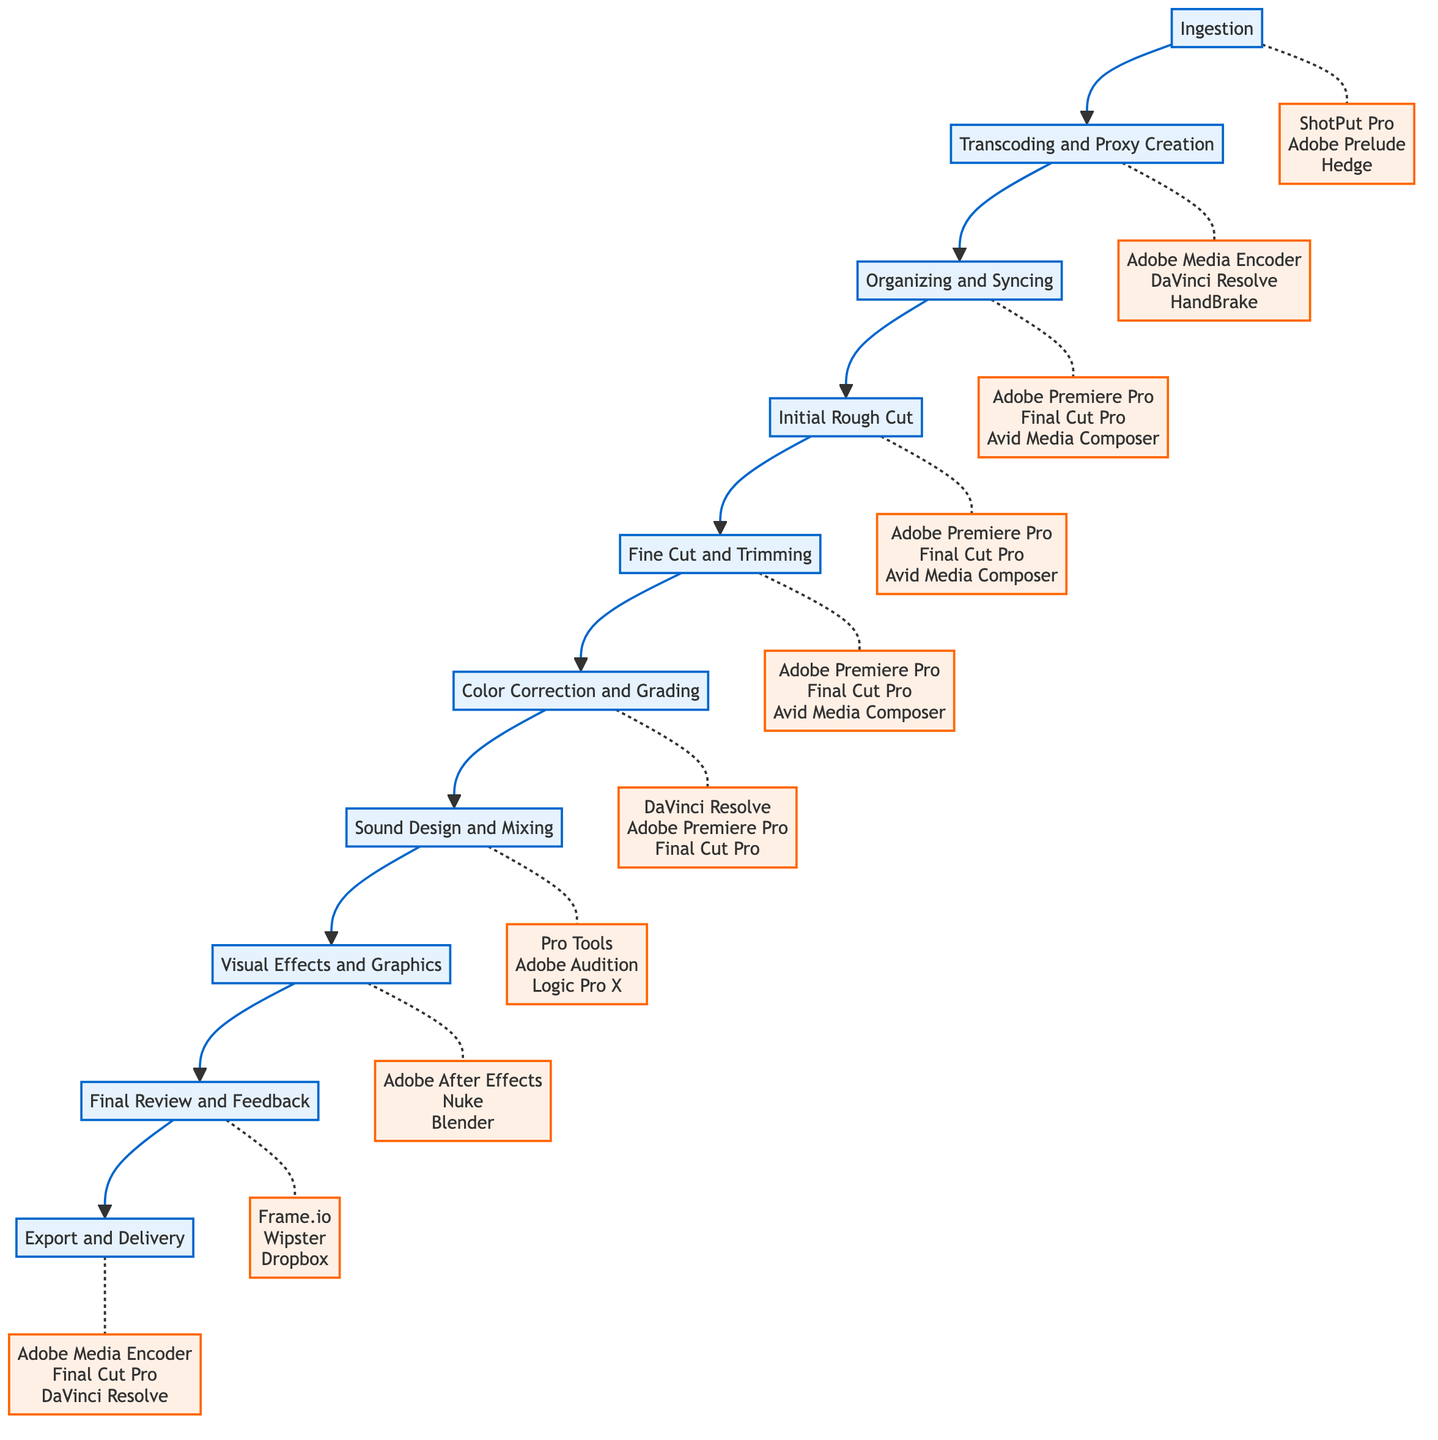What is the first step in the post-production workflow? The first node in the flow chart is labeled "Ingestion," which indicates that it is the starting point of the post-production process.
Answer: Ingestion How many steps are there in the post-production workflow? There are ten steps represented in the flow chart, each leading to the next in the process of post-production.
Answer: 10 What tools are used in the "Fine Cut and Trimming" step? The "Fine Cut and Trimming" step references three specific tools with the labels provided in the flow chart: "Adobe Premiere Pro," "Final Cut Pro," and "Avid Media Composer."
Answer: Adobe Premiere Pro, Final Cut Pro, Avid Media Composer What comes after "Color Correction and Grading"? By following the arrows in the flow chart, it can be observed that the next step after "Color Correction and Grading" is "Sound Design and Mixing," indicating the progression of tasks in the workflow.
Answer: Sound Design and Mixing How does "Transcoding and Proxy Creation" relate to "Ingestion"? The flow chart shows a direct arrow from "Ingestion" to "Transcoding and Proxy Creation," illustrating that transcoding occurs immediately after the ingestion of raw footage, representing a sequential relationship.
Answer: Transcoding and Proxy Creation Which step involves enhancing visual aesthetics? "Color Correction and Grading" is specifically named in the flow chart to indicate that it is the step focused on adjusting the visual aesthetics and color balance of the footage.
Answer: Color Correction and Grading Name a tool used in "Visual Effects and Graphics". The flow chart lists three tools under "Visual Effects and Graphics," including "Adobe After Effects," which is one of the specific tools designated for this step.
Answer: Adobe After Effects Which step must be completed before the "Final Review and Feedback"? The "Final Review and Feedback" step follows the "Visual Effects and Graphics" step, indicating that all graphics and visual effects must be finalized before this review can take place.
Answer: Visual Effects and Graphics What is the final step of the post-production workflow? The last step indicated in the flow chart is "Export and Delivery," which signifies the conclusion of the post-production process where the final film is exported and delivered.
Answer: Export and Delivery What tools are common in multiple steps of the workflow? The flow chart shows that "Adobe Premiere Pro," "Final Cut Pro," and "Avid Media Composer" appear in the steps "Organizing and Syncing," "Initial Rough Cut," and "Fine Cut and Trimming," indicating their common usage across these stages.
Answer: Adobe Premiere Pro, Final Cut Pro, Avid Media Composer 